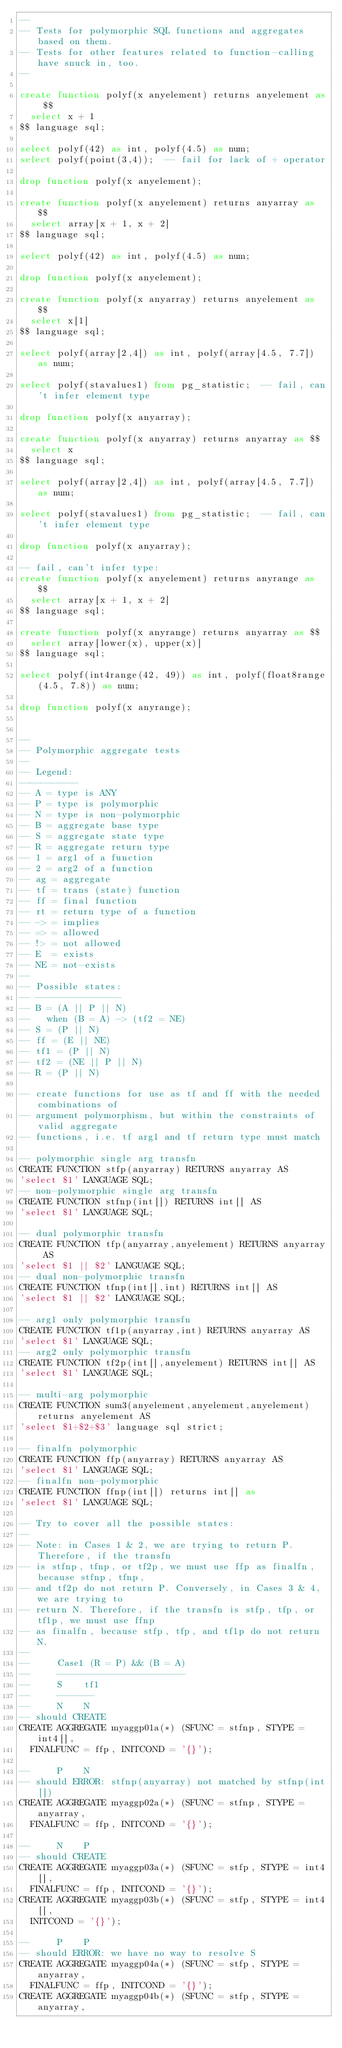<code> <loc_0><loc_0><loc_500><loc_500><_SQL_>--
-- Tests for polymorphic SQL functions and aggregates based on them.
-- Tests for other features related to function-calling have snuck in, too.
--

create function polyf(x anyelement) returns anyelement as $$
  select x + 1
$$ language sql;

select polyf(42) as int, polyf(4.5) as num;
select polyf(point(3,4));  -- fail for lack of + operator

drop function polyf(x anyelement);

create function polyf(x anyelement) returns anyarray as $$
  select array[x + 1, x + 2]
$$ language sql;

select polyf(42) as int, polyf(4.5) as num;

drop function polyf(x anyelement);

create function polyf(x anyarray) returns anyelement as $$
  select x[1]
$$ language sql;

select polyf(array[2,4]) as int, polyf(array[4.5, 7.7]) as num;

select polyf(stavalues1) from pg_statistic;  -- fail, can't infer element type

drop function polyf(x anyarray);

create function polyf(x anyarray) returns anyarray as $$
  select x
$$ language sql;

select polyf(array[2,4]) as int, polyf(array[4.5, 7.7]) as num;

select polyf(stavalues1) from pg_statistic;  -- fail, can't infer element type

drop function polyf(x anyarray);

-- fail, can't infer type:
create function polyf(x anyelement) returns anyrange as $$
  select array[x + 1, x + 2]
$$ language sql;

create function polyf(x anyrange) returns anyarray as $$
  select array[lower(x), upper(x)]
$$ language sql;

select polyf(int4range(42, 49)) as int, polyf(float8range(4.5, 7.8)) as num;

drop function polyf(x anyrange);


--
-- Polymorphic aggregate tests
--
-- Legend:
-----------
-- A = type is ANY
-- P = type is polymorphic
-- N = type is non-polymorphic
-- B = aggregate base type
-- S = aggregate state type
-- R = aggregate return type
-- 1 = arg1 of a function
-- 2 = arg2 of a function
-- ag = aggregate
-- tf = trans (state) function
-- ff = final function
-- rt = return type of a function
-- -> = implies
-- => = allowed
-- !> = not allowed
-- E  = exists
-- NE = not-exists
--
-- Possible states:
-- ----------------
-- B = (A || P || N)
--   when (B = A) -> (tf2 = NE)
-- S = (P || N)
-- ff = (E || NE)
-- tf1 = (P || N)
-- tf2 = (NE || P || N)
-- R = (P || N)

-- create functions for use as tf and ff with the needed combinations of
-- argument polymorphism, but within the constraints of valid aggregate
-- functions, i.e. tf arg1 and tf return type must match

-- polymorphic single arg transfn
CREATE FUNCTION stfp(anyarray) RETURNS anyarray AS
'select $1' LANGUAGE SQL;
-- non-polymorphic single arg transfn
CREATE FUNCTION stfnp(int[]) RETURNS int[] AS
'select $1' LANGUAGE SQL;

-- dual polymorphic transfn
CREATE FUNCTION tfp(anyarray,anyelement) RETURNS anyarray AS
'select $1 || $2' LANGUAGE SQL;
-- dual non-polymorphic transfn
CREATE FUNCTION tfnp(int[],int) RETURNS int[] AS
'select $1 || $2' LANGUAGE SQL;

-- arg1 only polymorphic transfn
CREATE FUNCTION tf1p(anyarray,int) RETURNS anyarray AS
'select $1' LANGUAGE SQL;
-- arg2 only polymorphic transfn
CREATE FUNCTION tf2p(int[],anyelement) RETURNS int[] AS
'select $1' LANGUAGE SQL;

-- multi-arg polymorphic
CREATE FUNCTION sum3(anyelement,anyelement,anyelement) returns anyelement AS
'select $1+$2+$3' language sql strict;

-- finalfn polymorphic
CREATE FUNCTION ffp(anyarray) RETURNS anyarray AS
'select $1' LANGUAGE SQL;
-- finalfn non-polymorphic
CREATE FUNCTION ffnp(int[]) returns int[] as
'select $1' LANGUAGE SQL;

-- Try to cover all the possible states:
--
-- Note: in Cases 1 & 2, we are trying to return P. Therefore, if the transfn
-- is stfnp, tfnp, or tf2p, we must use ffp as finalfn, because stfnp, tfnp,
-- and tf2p do not return P. Conversely, in Cases 3 & 4, we are trying to
-- return N. Therefore, if the transfn is stfp, tfp, or tf1p, we must use ffnp
-- as finalfn, because stfp, tfp, and tf1p do not return N.
--
--     Case1 (R = P) && (B = A)
--     ------------------------
--     S    tf1
--     -------
--     N    N
-- should CREATE
CREATE AGGREGATE myaggp01a(*) (SFUNC = stfnp, STYPE = int4[],
  FINALFUNC = ffp, INITCOND = '{}');

--     P    N
-- should ERROR: stfnp(anyarray) not matched by stfnp(int[])
CREATE AGGREGATE myaggp02a(*) (SFUNC = stfnp, STYPE = anyarray,
  FINALFUNC = ffp, INITCOND = '{}');

--     N    P
-- should CREATE
CREATE AGGREGATE myaggp03a(*) (SFUNC = stfp, STYPE = int4[],
  FINALFUNC = ffp, INITCOND = '{}');
CREATE AGGREGATE myaggp03b(*) (SFUNC = stfp, STYPE = int4[],
  INITCOND = '{}');

--     P    P
-- should ERROR: we have no way to resolve S
CREATE AGGREGATE myaggp04a(*) (SFUNC = stfp, STYPE = anyarray,
  FINALFUNC = ffp, INITCOND = '{}');
CREATE AGGREGATE myaggp04b(*) (SFUNC = stfp, STYPE = anyarray,</code> 